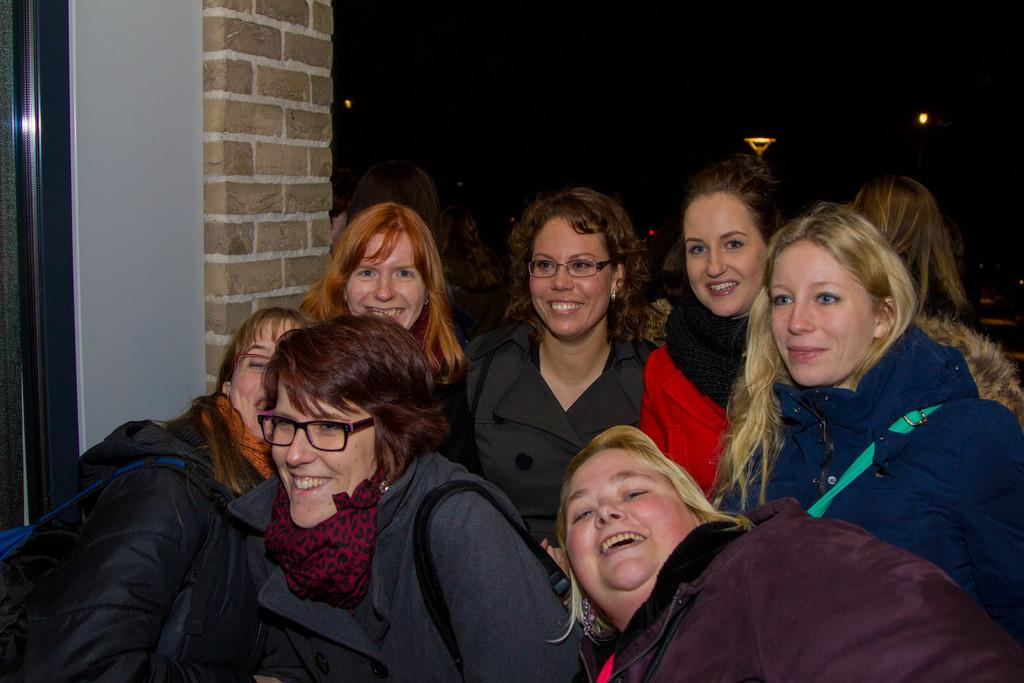What is happening at the bottom of the image? There is a group of persons standing at the bottom of the image. What can be seen on the left side of the image? There is a wall on the left side of the image. What is located at the top of the image? There is a light at the top of the image. What type of net is being used by the persons in the image? There is no net present in the image; it only shows a group of persons standing at the bottom, a wall on the left side, and a light at the top. What color is the polish on the wall in the image? There is no mention of polish or any specific color on the wall in the image. 